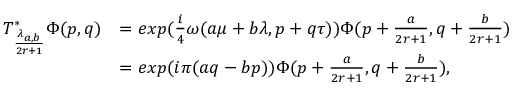Convert formula to latex. <formula><loc_0><loc_0><loc_500><loc_500>\begin{array} { r l } { T _ { \frac { \lambda _ { a , b } } { 2 r + 1 } } ^ { * } \Phi ( p , q ) } & { = e x p ( \frac { i } { 4 } \omega ( a \mu + b \lambda , p + q \tau ) ) \Phi ( p + \frac { a } { 2 r + 1 } , q + \frac { b } { 2 r + 1 } ) } \\ & { = e x p ( i \pi ( a q - b p ) ) \Phi ( p + \frac { a } { 2 r + 1 } , q + \frac { b } { 2 r + 1 } ) , } \end{array}</formula> 